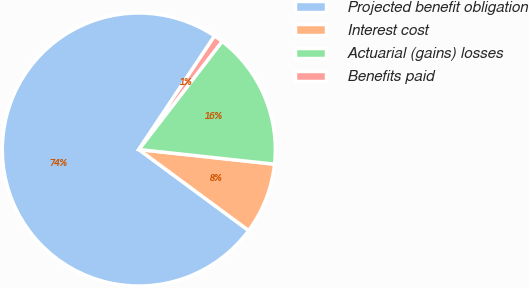Convert chart to OTSL. <chart><loc_0><loc_0><loc_500><loc_500><pie_chart><fcel>Projected benefit obligation<fcel>Interest cost<fcel>Actuarial (gains) losses<fcel>Benefits paid<nl><fcel>74.25%<fcel>8.4%<fcel>16.27%<fcel>1.08%<nl></chart> 